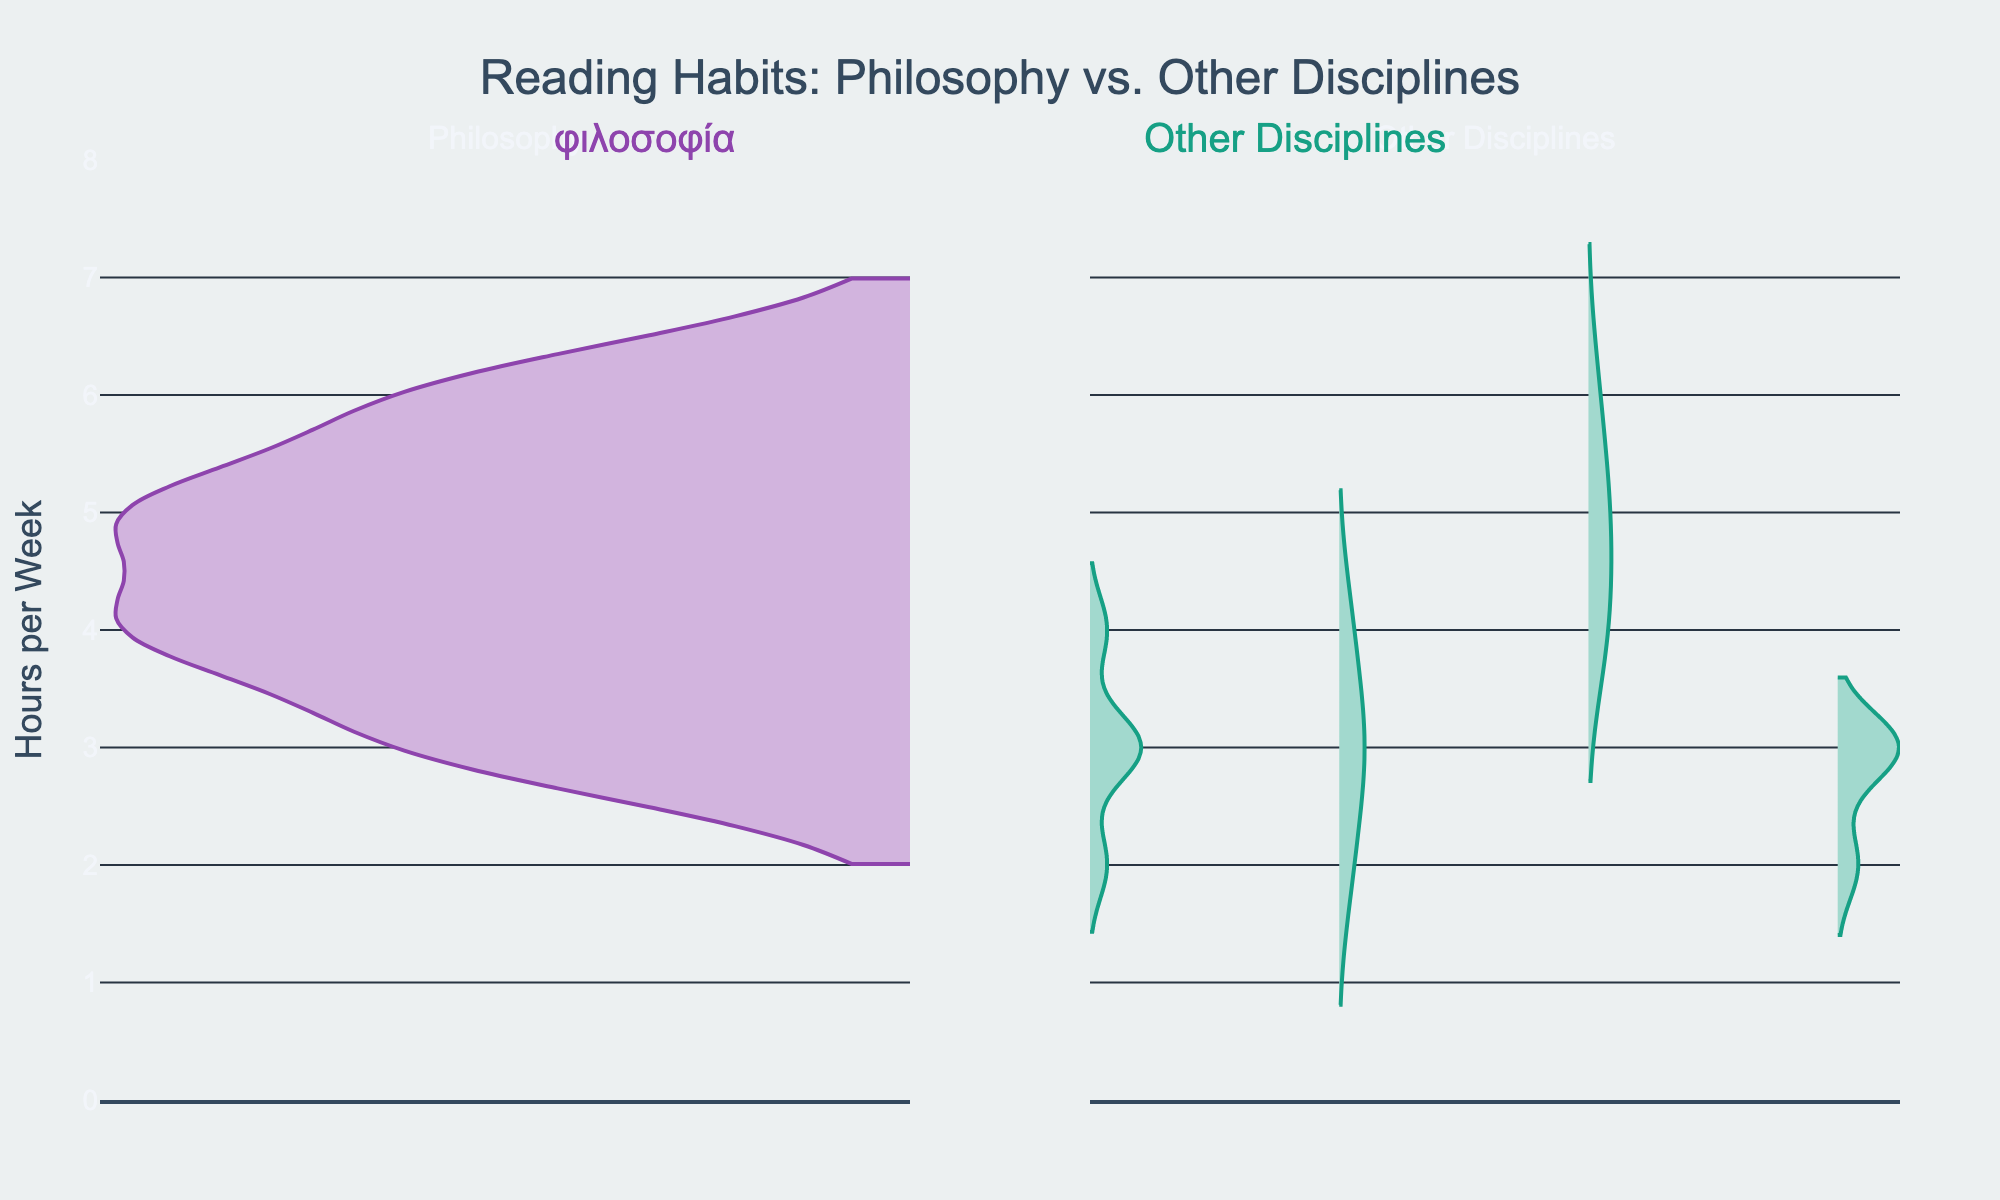What is the title of the figure? The title is located at the top center of the figure and reads "Reading Habits: Philosophy vs. Other Disciplines"
Answer: Reading Habits: Philosophy vs. Other Disciplines How many hours per week do students majoring in Philosophy typically read? The distribution of hours per week for Philosophy majors can be seen on the violin chart on the left side. Most data points seem to cluster around 4 to 6 hours per week.
Answer: 4 to 6 hours Which major has more variability in reading hours, Philosophy or other disciplines? By comparing the spread of the violins on both sides, we see that the Philosophy violin has a narrower and more concentrated distribution, whereas the Other Disciplines violin appears more spread out, indicating more variability.
Answer: Other Disciplines What is the range of hours per week depicted for students majoring in Other Disciplines? The range can be deduced by looking at the extent of the violin plot for Other Disciplines. It ranges from about 2 to 6 hours per week.
Answer: 2 to 6 hours per week How does the average reading time for Philosophy compare to Other Disciplines? By visual inspection, the center of the concentration for Philosophy readings clusters around 4-5 hours per week whereas Other Disciplines show a more even spread around 3-4 hours. This suggests Philosophy may have a slightly higher average.
Answer: Philosophy is slightly higher Which side of the chart represents Philosophy, and what color is used for it? The left side of the chart represents Philosophy, and it is colored with shades of purple.
Answer: Left side, purple What is one of the books read by Philosophy students mentioned in the data? The figure does not label specific book names, but we know from the provided data that one of the books is "Plato's Republic."
Answer: Plato's Republic Based on the figure, can we determine if Philosophy students read more consistently in terms of hours per week compared to students in other disciplines? Yes, Philosophy students appear to read more consistently, as evidenced by the more concentrated distribution of hours in the violin plot as compared to the broader distribution for Other Disciplines.
Answer: Yes Are there any students, regardless of major, who read less than 2 hours per week? No, the violin plots for both Philosophy and Other Disciplines show that the minimum reading time starts at 2 hours per week.
Answer: No How does the visual appearance of the violin chart suggest the reading habits between Philosophy and Other Disciplines? The denser, narrower distribution of Philosophy suggests consistent reading activity around specific hours. In contrast, the broader and more varied distribution of Other Disciplines suggests a wider range of reading habits.
Answer: Philosophy is more consistent, Other Disciplines are more varied 